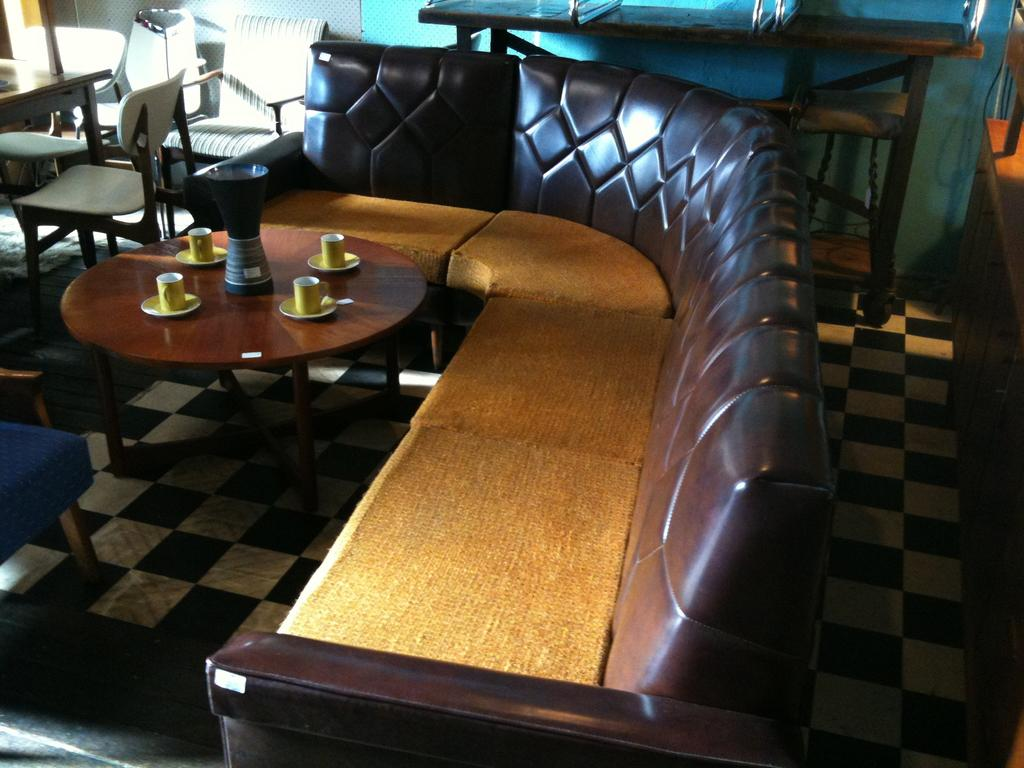What type of furniture is in the image? There is a sofa bed in the image. What objects are present that might be used for drinking? There are cups in the image. What can be seen on a table in the image? There is a flask on a table in the image. What type of learning instrument is present in the image? There is no learning instrument present in the image. What is the condition of the sofa bed in the image? The condition of the sofa bed cannot be determined from the image alone. 